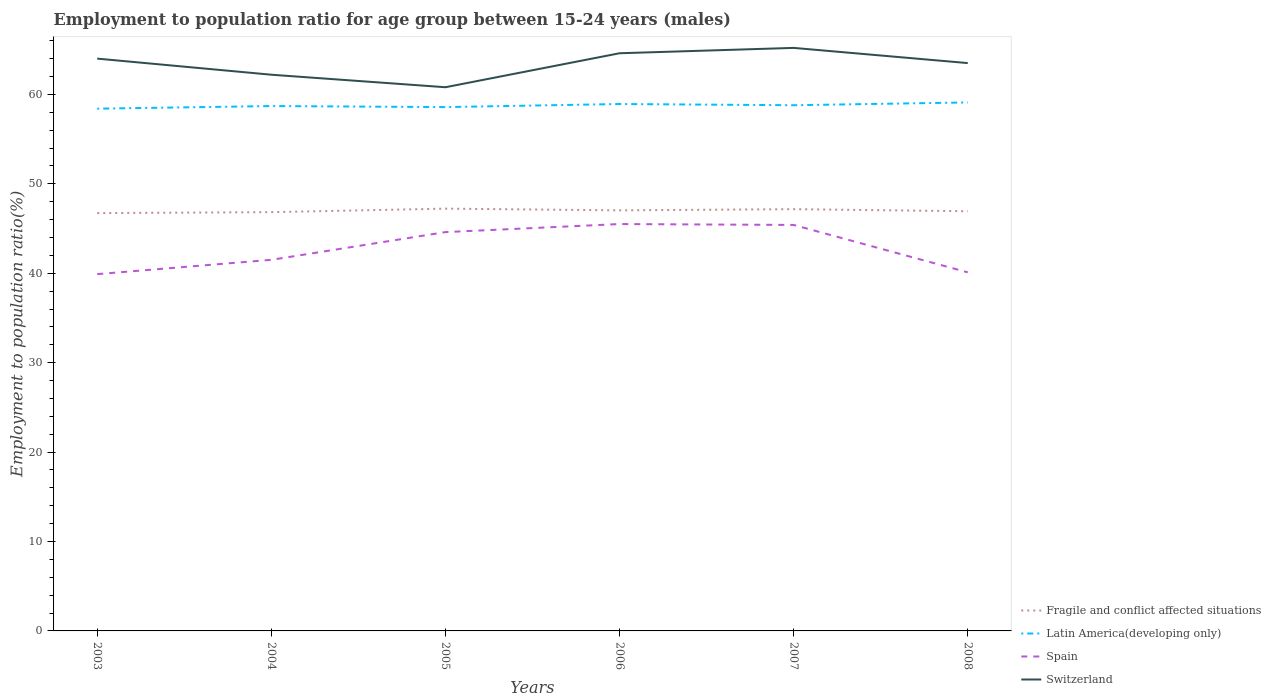How many different coloured lines are there?
Give a very brief answer. 4. Across all years, what is the maximum employment to population ratio in Fragile and conflict affected situations?
Offer a terse response. 46.72. What is the total employment to population ratio in Latin America(developing only) in the graph?
Give a very brief answer. -0.4. What is the difference between the highest and the second highest employment to population ratio in Spain?
Your answer should be very brief. 5.6. Is the employment to population ratio in Spain strictly greater than the employment to population ratio in Latin America(developing only) over the years?
Make the answer very short. Yes. How many years are there in the graph?
Give a very brief answer. 6. Does the graph contain any zero values?
Offer a terse response. No. Does the graph contain grids?
Make the answer very short. No. Where does the legend appear in the graph?
Provide a succinct answer. Bottom right. How many legend labels are there?
Offer a terse response. 4. How are the legend labels stacked?
Your answer should be compact. Vertical. What is the title of the graph?
Give a very brief answer. Employment to population ratio for age group between 15-24 years (males). Does "Guyana" appear as one of the legend labels in the graph?
Keep it short and to the point. No. What is the label or title of the X-axis?
Make the answer very short. Years. What is the label or title of the Y-axis?
Your response must be concise. Employment to population ratio(%). What is the Employment to population ratio(%) in Fragile and conflict affected situations in 2003?
Your answer should be compact. 46.72. What is the Employment to population ratio(%) of Latin America(developing only) in 2003?
Ensure brevity in your answer.  58.4. What is the Employment to population ratio(%) in Spain in 2003?
Give a very brief answer. 39.9. What is the Employment to population ratio(%) in Fragile and conflict affected situations in 2004?
Keep it short and to the point. 46.83. What is the Employment to population ratio(%) in Latin America(developing only) in 2004?
Ensure brevity in your answer.  58.7. What is the Employment to population ratio(%) in Spain in 2004?
Offer a very short reply. 41.5. What is the Employment to population ratio(%) in Switzerland in 2004?
Your answer should be compact. 62.2. What is the Employment to population ratio(%) of Fragile and conflict affected situations in 2005?
Ensure brevity in your answer.  47.22. What is the Employment to population ratio(%) of Latin America(developing only) in 2005?
Provide a short and direct response. 58.58. What is the Employment to population ratio(%) of Spain in 2005?
Provide a short and direct response. 44.6. What is the Employment to population ratio(%) of Switzerland in 2005?
Keep it short and to the point. 60.8. What is the Employment to population ratio(%) of Fragile and conflict affected situations in 2006?
Offer a terse response. 47.03. What is the Employment to population ratio(%) of Latin America(developing only) in 2006?
Your answer should be very brief. 58.92. What is the Employment to population ratio(%) of Spain in 2006?
Make the answer very short. 45.5. What is the Employment to population ratio(%) of Switzerland in 2006?
Offer a terse response. 64.6. What is the Employment to population ratio(%) in Fragile and conflict affected situations in 2007?
Your answer should be very brief. 47.16. What is the Employment to population ratio(%) in Latin America(developing only) in 2007?
Ensure brevity in your answer.  58.79. What is the Employment to population ratio(%) of Spain in 2007?
Offer a terse response. 45.4. What is the Employment to population ratio(%) in Switzerland in 2007?
Keep it short and to the point. 65.2. What is the Employment to population ratio(%) in Fragile and conflict affected situations in 2008?
Offer a terse response. 46.93. What is the Employment to population ratio(%) in Latin America(developing only) in 2008?
Your answer should be very brief. 59.1. What is the Employment to population ratio(%) of Spain in 2008?
Your answer should be compact. 40.1. What is the Employment to population ratio(%) of Switzerland in 2008?
Your answer should be compact. 63.5. Across all years, what is the maximum Employment to population ratio(%) in Fragile and conflict affected situations?
Offer a very short reply. 47.22. Across all years, what is the maximum Employment to population ratio(%) of Latin America(developing only)?
Offer a terse response. 59.1. Across all years, what is the maximum Employment to population ratio(%) in Spain?
Offer a very short reply. 45.5. Across all years, what is the maximum Employment to population ratio(%) in Switzerland?
Keep it short and to the point. 65.2. Across all years, what is the minimum Employment to population ratio(%) of Fragile and conflict affected situations?
Make the answer very short. 46.72. Across all years, what is the minimum Employment to population ratio(%) in Latin America(developing only)?
Keep it short and to the point. 58.4. Across all years, what is the minimum Employment to population ratio(%) in Spain?
Give a very brief answer. 39.9. Across all years, what is the minimum Employment to population ratio(%) in Switzerland?
Keep it short and to the point. 60.8. What is the total Employment to population ratio(%) in Fragile and conflict affected situations in the graph?
Give a very brief answer. 281.91. What is the total Employment to population ratio(%) of Latin America(developing only) in the graph?
Give a very brief answer. 352.49. What is the total Employment to population ratio(%) of Spain in the graph?
Your response must be concise. 257. What is the total Employment to population ratio(%) in Switzerland in the graph?
Make the answer very short. 380.3. What is the difference between the Employment to population ratio(%) in Fragile and conflict affected situations in 2003 and that in 2004?
Your answer should be compact. -0.11. What is the difference between the Employment to population ratio(%) of Latin America(developing only) in 2003 and that in 2004?
Provide a succinct answer. -0.29. What is the difference between the Employment to population ratio(%) of Spain in 2003 and that in 2004?
Ensure brevity in your answer.  -1.6. What is the difference between the Employment to population ratio(%) of Switzerland in 2003 and that in 2004?
Your response must be concise. 1.8. What is the difference between the Employment to population ratio(%) in Fragile and conflict affected situations in 2003 and that in 2005?
Give a very brief answer. -0.5. What is the difference between the Employment to population ratio(%) of Latin America(developing only) in 2003 and that in 2005?
Give a very brief answer. -0.18. What is the difference between the Employment to population ratio(%) of Switzerland in 2003 and that in 2005?
Ensure brevity in your answer.  3.2. What is the difference between the Employment to population ratio(%) in Fragile and conflict affected situations in 2003 and that in 2006?
Provide a short and direct response. -0.31. What is the difference between the Employment to population ratio(%) of Latin America(developing only) in 2003 and that in 2006?
Offer a terse response. -0.52. What is the difference between the Employment to population ratio(%) in Fragile and conflict affected situations in 2003 and that in 2007?
Keep it short and to the point. -0.44. What is the difference between the Employment to population ratio(%) of Latin America(developing only) in 2003 and that in 2007?
Provide a succinct answer. -0.39. What is the difference between the Employment to population ratio(%) in Fragile and conflict affected situations in 2003 and that in 2008?
Your answer should be very brief. -0.21. What is the difference between the Employment to population ratio(%) in Latin America(developing only) in 2003 and that in 2008?
Keep it short and to the point. -0.7. What is the difference between the Employment to population ratio(%) of Spain in 2003 and that in 2008?
Your response must be concise. -0.2. What is the difference between the Employment to population ratio(%) of Fragile and conflict affected situations in 2004 and that in 2005?
Provide a short and direct response. -0.39. What is the difference between the Employment to population ratio(%) in Latin America(developing only) in 2004 and that in 2005?
Give a very brief answer. 0.12. What is the difference between the Employment to population ratio(%) in Spain in 2004 and that in 2005?
Make the answer very short. -3.1. What is the difference between the Employment to population ratio(%) in Fragile and conflict affected situations in 2004 and that in 2006?
Give a very brief answer. -0.2. What is the difference between the Employment to population ratio(%) in Latin America(developing only) in 2004 and that in 2006?
Give a very brief answer. -0.23. What is the difference between the Employment to population ratio(%) in Switzerland in 2004 and that in 2006?
Your answer should be very brief. -2.4. What is the difference between the Employment to population ratio(%) in Fragile and conflict affected situations in 2004 and that in 2007?
Your response must be concise. -0.33. What is the difference between the Employment to population ratio(%) of Latin America(developing only) in 2004 and that in 2007?
Make the answer very short. -0.09. What is the difference between the Employment to population ratio(%) of Fragile and conflict affected situations in 2004 and that in 2008?
Your response must be concise. -0.1. What is the difference between the Employment to population ratio(%) of Latin America(developing only) in 2004 and that in 2008?
Provide a succinct answer. -0.4. What is the difference between the Employment to population ratio(%) of Spain in 2004 and that in 2008?
Make the answer very short. 1.4. What is the difference between the Employment to population ratio(%) in Fragile and conflict affected situations in 2005 and that in 2006?
Ensure brevity in your answer.  0.19. What is the difference between the Employment to population ratio(%) of Latin America(developing only) in 2005 and that in 2006?
Make the answer very short. -0.34. What is the difference between the Employment to population ratio(%) in Spain in 2005 and that in 2006?
Your answer should be compact. -0.9. What is the difference between the Employment to population ratio(%) of Switzerland in 2005 and that in 2006?
Offer a terse response. -3.8. What is the difference between the Employment to population ratio(%) of Fragile and conflict affected situations in 2005 and that in 2007?
Offer a very short reply. 0.06. What is the difference between the Employment to population ratio(%) of Latin America(developing only) in 2005 and that in 2007?
Give a very brief answer. -0.21. What is the difference between the Employment to population ratio(%) in Fragile and conflict affected situations in 2005 and that in 2008?
Provide a short and direct response. 0.29. What is the difference between the Employment to population ratio(%) in Latin America(developing only) in 2005 and that in 2008?
Give a very brief answer. -0.52. What is the difference between the Employment to population ratio(%) of Spain in 2005 and that in 2008?
Offer a very short reply. 4.5. What is the difference between the Employment to population ratio(%) in Switzerland in 2005 and that in 2008?
Your answer should be compact. -2.7. What is the difference between the Employment to population ratio(%) in Fragile and conflict affected situations in 2006 and that in 2007?
Provide a short and direct response. -0.13. What is the difference between the Employment to population ratio(%) in Latin America(developing only) in 2006 and that in 2007?
Your answer should be compact. 0.13. What is the difference between the Employment to population ratio(%) in Spain in 2006 and that in 2007?
Offer a very short reply. 0.1. What is the difference between the Employment to population ratio(%) in Fragile and conflict affected situations in 2006 and that in 2008?
Ensure brevity in your answer.  0.1. What is the difference between the Employment to population ratio(%) in Latin America(developing only) in 2006 and that in 2008?
Your answer should be very brief. -0.18. What is the difference between the Employment to population ratio(%) of Fragile and conflict affected situations in 2007 and that in 2008?
Ensure brevity in your answer.  0.23. What is the difference between the Employment to population ratio(%) in Latin America(developing only) in 2007 and that in 2008?
Your response must be concise. -0.31. What is the difference between the Employment to population ratio(%) of Switzerland in 2007 and that in 2008?
Your response must be concise. 1.7. What is the difference between the Employment to population ratio(%) in Fragile and conflict affected situations in 2003 and the Employment to population ratio(%) in Latin America(developing only) in 2004?
Make the answer very short. -11.97. What is the difference between the Employment to population ratio(%) of Fragile and conflict affected situations in 2003 and the Employment to population ratio(%) of Spain in 2004?
Give a very brief answer. 5.22. What is the difference between the Employment to population ratio(%) of Fragile and conflict affected situations in 2003 and the Employment to population ratio(%) of Switzerland in 2004?
Make the answer very short. -15.48. What is the difference between the Employment to population ratio(%) in Latin America(developing only) in 2003 and the Employment to population ratio(%) in Spain in 2004?
Your response must be concise. 16.9. What is the difference between the Employment to population ratio(%) in Latin America(developing only) in 2003 and the Employment to population ratio(%) in Switzerland in 2004?
Keep it short and to the point. -3.8. What is the difference between the Employment to population ratio(%) in Spain in 2003 and the Employment to population ratio(%) in Switzerland in 2004?
Provide a short and direct response. -22.3. What is the difference between the Employment to population ratio(%) of Fragile and conflict affected situations in 2003 and the Employment to population ratio(%) of Latin America(developing only) in 2005?
Make the answer very short. -11.86. What is the difference between the Employment to population ratio(%) of Fragile and conflict affected situations in 2003 and the Employment to population ratio(%) of Spain in 2005?
Make the answer very short. 2.12. What is the difference between the Employment to population ratio(%) in Fragile and conflict affected situations in 2003 and the Employment to population ratio(%) in Switzerland in 2005?
Keep it short and to the point. -14.08. What is the difference between the Employment to population ratio(%) of Latin America(developing only) in 2003 and the Employment to population ratio(%) of Spain in 2005?
Offer a very short reply. 13.8. What is the difference between the Employment to population ratio(%) of Latin America(developing only) in 2003 and the Employment to population ratio(%) of Switzerland in 2005?
Your answer should be compact. -2.4. What is the difference between the Employment to population ratio(%) in Spain in 2003 and the Employment to population ratio(%) in Switzerland in 2005?
Your answer should be compact. -20.9. What is the difference between the Employment to population ratio(%) of Fragile and conflict affected situations in 2003 and the Employment to population ratio(%) of Latin America(developing only) in 2006?
Offer a terse response. -12.2. What is the difference between the Employment to population ratio(%) in Fragile and conflict affected situations in 2003 and the Employment to population ratio(%) in Spain in 2006?
Offer a very short reply. 1.22. What is the difference between the Employment to population ratio(%) of Fragile and conflict affected situations in 2003 and the Employment to population ratio(%) of Switzerland in 2006?
Offer a very short reply. -17.88. What is the difference between the Employment to population ratio(%) in Latin America(developing only) in 2003 and the Employment to population ratio(%) in Spain in 2006?
Offer a very short reply. 12.9. What is the difference between the Employment to population ratio(%) of Latin America(developing only) in 2003 and the Employment to population ratio(%) of Switzerland in 2006?
Provide a short and direct response. -6.2. What is the difference between the Employment to population ratio(%) of Spain in 2003 and the Employment to population ratio(%) of Switzerland in 2006?
Offer a very short reply. -24.7. What is the difference between the Employment to population ratio(%) of Fragile and conflict affected situations in 2003 and the Employment to population ratio(%) of Latin America(developing only) in 2007?
Make the answer very short. -12.06. What is the difference between the Employment to population ratio(%) in Fragile and conflict affected situations in 2003 and the Employment to population ratio(%) in Spain in 2007?
Your answer should be compact. 1.32. What is the difference between the Employment to population ratio(%) in Fragile and conflict affected situations in 2003 and the Employment to population ratio(%) in Switzerland in 2007?
Ensure brevity in your answer.  -18.48. What is the difference between the Employment to population ratio(%) in Latin America(developing only) in 2003 and the Employment to population ratio(%) in Spain in 2007?
Your answer should be very brief. 13. What is the difference between the Employment to population ratio(%) of Latin America(developing only) in 2003 and the Employment to population ratio(%) of Switzerland in 2007?
Give a very brief answer. -6.8. What is the difference between the Employment to population ratio(%) in Spain in 2003 and the Employment to population ratio(%) in Switzerland in 2007?
Offer a terse response. -25.3. What is the difference between the Employment to population ratio(%) of Fragile and conflict affected situations in 2003 and the Employment to population ratio(%) of Latin America(developing only) in 2008?
Your response must be concise. -12.38. What is the difference between the Employment to population ratio(%) of Fragile and conflict affected situations in 2003 and the Employment to population ratio(%) of Spain in 2008?
Offer a very short reply. 6.62. What is the difference between the Employment to population ratio(%) of Fragile and conflict affected situations in 2003 and the Employment to population ratio(%) of Switzerland in 2008?
Your answer should be very brief. -16.78. What is the difference between the Employment to population ratio(%) in Latin America(developing only) in 2003 and the Employment to population ratio(%) in Spain in 2008?
Keep it short and to the point. 18.3. What is the difference between the Employment to population ratio(%) in Latin America(developing only) in 2003 and the Employment to population ratio(%) in Switzerland in 2008?
Your response must be concise. -5.1. What is the difference between the Employment to population ratio(%) in Spain in 2003 and the Employment to population ratio(%) in Switzerland in 2008?
Ensure brevity in your answer.  -23.6. What is the difference between the Employment to population ratio(%) of Fragile and conflict affected situations in 2004 and the Employment to population ratio(%) of Latin America(developing only) in 2005?
Keep it short and to the point. -11.75. What is the difference between the Employment to population ratio(%) in Fragile and conflict affected situations in 2004 and the Employment to population ratio(%) in Spain in 2005?
Provide a short and direct response. 2.23. What is the difference between the Employment to population ratio(%) in Fragile and conflict affected situations in 2004 and the Employment to population ratio(%) in Switzerland in 2005?
Offer a very short reply. -13.97. What is the difference between the Employment to population ratio(%) of Latin America(developing only) in 2004 and the Employment to population ratio(%) of Spain in 2005?
Your response must be concise. 14.1. What is the difference between the Employment to population ratio(%) of Latin America(developing only) in 2004 and the Employment to population ratio(%) of Switzerland in 2005?
Make the answer very short. -2.1. What is the difference between the Employment to population ratio(%) of Spain in 2004 and the Employment to population ratio(%) of Switzerland in 2005?
Offer a very short reply. -19.3. What is the difference between the Employment to population ratio(%) in Fragile and conflict affected situations in 2004 and the Employment to population ratio(%) in Latin America(developing only) in 2006?
Give a very brief answer. -12.09. What is the difference between the Employment to population ratio(%) of Fragile and conflict affected situations in 2004 and the Employment to population ratio(%) of Spain in 2006?
Ensure brevity in your answer.  1.33. What is the difference between the Employment to population ratio(%) of Fragile and conflict affected situations in 2004 and the Employment to population ratio(%) of Switzerland in 2006?
Keep it short and to the point. -17.77. What is the difference between the Employment to population ratio(%) of Latin America(developing only) in 2004 and the Employment to population ratio(%) of Spain in 2006?
Offer a terse response. 13.2. What is the difference between the Employment to population ratio(%) of Latin America(developing only) in 2004 and the Employment to population ratio(%) of Switzerland in 2006?
Make the answer very short. -5.9. What is the difference between the Employment to population ratio(%) in Spain in 2004 and the Employment to population ratio(%) in Switzerland in 2006?
Ensure brevity in your answer.  -23.1. What is the difference between the Employment to population ratio(%) of Fragile and conflict affected situations in 2004 and the Employment to population ratio(%) of Latin America(developing only) in 2007?
Your answer should be compact. -11.96. What is the difference between the Employment to population ratio(%) of Fragile and conflict affected situations in 2004 and the Employment to population ratio(%) of Spain in 2007?
Provide a succinct answer. 1.43. What is the difference between the Employment to population ratio(%) of Fragile and conflict affected situations in 2004 and the Employment to population ratio(%) of Switzerland in 2007?
Provide a succinct answer. -18.37. What is the difference between the Employment to population ratio(%) of Latin America(developing only) in 2004 and the Employment to population ratio(%) of Spain in 2007?
Your answer should be very brief. 13.3. What is the difference between the Employment to population ratio(%) in Latin America(developing only) in 2004 and the Employment to population ratio(%) in Switzerland in 2007?
Ensure brevity in your answer.  -6.5. What is the difference between the Employment to population ratio(%) in Spain in 2004 and the Employment to population ratio(%) in Switzerland in 2007?
Your answer should be compact. -23.7. What is the difference between the Employment to population ratio(%) of Fragile and conflict affected situations in 2004 and the Employment to population ratio(%) of Latin America(developing only) in 2008?
Ensure brevity in your answer.  -12.27. What is the difference between the Employment to population ratio(%) in Fragile and conflict affected situations in 2004 and the Employment to population ratio(%) in Spain in 2008?
Give a very brief answer. 6.73. What is the difference between the Employment to population ratio(%) of Fragile and conflict affected situations in 2004 and the Employment to population ratio(%) of Switzerland in 2008?
Offer a very short reply. -16.67. What is the difference between the Employment to population ratio(%) of Latin America(developing only) in 2004 and the Employment to population ratio(%) of Spain in 2008?
Provide a short and direct response. 18.6. What is the difference between the Employment to population ratio(%) of Latin America(developing only) in 2004 and the Employment to population ratio(%) of Switzerland in 2008?
Give a very brief answer. -4.8. What is the difference between the Employment to population ratio(%) of Fragile and conflict affected situations in 2005 and the Employment to population ratio(%) of Latin America(developing only) in 2006?
Your answer should be compact. -11.7. What is the difference between the Employment to population ratio(%) of Fragile and conflict affected situations in 2005 and the Employment to population ratio(%) of Spain in 2006?
Make the answer very short. 1.72. What is the difference between the Employment to population ratio(%) of Fragile and conflict affected situations in 2005 and the Employment to population ratio(%) of Switzerland in 2006?
Keep it short and to the point. -17.38. What is the difference between the Employment to population ratio(%) of Latin America(developing only) in 2005 and the Employment to population ratio(%) of Spain in 2006?
Your response must be concise. 13.08. What is the difference between the Employment to population ratio(%) of Latin America(developing only) in 2005 and the Employment to population ratio(%) of Switzerland in 2006?
Ensure brevity in your answer.  -6.02. What is the difference between the Employment to population ratio(%) of Spain in 2005 and the Employment to population ratio(%) of Switzerland in 2006?
Offer a very short reply. -20. What is the difference between the Employment to population ratio(%) in Fragile and conflict affected situations in 2005 and the Employment to population ratio(%) in Latin America(developing only) in 2007?
Your answer should be very brief. -11.57. What is the difference between the Employment to population ratio(%) in Fragile and conflict affected situations in 2005 and the Employment to population ratio(%) in Spain in 2007?
Keep it short and to the point. 1.82. What is the difference between the Employment to population ratio(%) in Fragile and conflict affected situations in 2005 and the Employment to population ratio(%) in Switzerland in 2007?
Give a very brief answer. -17.98. What is the difference between the Employment to population ratio(%) in Latin America(developing only) in 2005 and the Employment to population ratio(%) in Spain in 2007?
Offer a very short reply. 13.18. What is the difference between the Employment to population ratio(%) of Latin America(developing only) in 2005 and the Employment to population ratio(%) of Switzerland in 2007?
Your response must be concise. -6.62. What is the difference between the Employment to population ratio(%) of Spain in 2005 and the Employment to population ratio(%) of Switzerland in 2007?
Give a very brief answer. -20.6. What is the difference between the Employment to population ratio(%) in Fragile and conflict affected situations in 2005 and the Employment to population ratio(%) in Latin America(developing only) in 2008?
Offer a terse response. -11.88. What is the difference between the Employment to population ratio(%) of Fragile and conflict affected situations in 2005 and the Employment to population ratio(%) of Spain in 2008?
Offer a terse response. 7.12. What is the difference between the Employment to population ratio(%) of Fragile and conflict affected situations in 2005 and the Employment to population ratio(%) of Switzerland in 2008?
Ensure brevity in your answer.  -16.28. What is the difference between the Employment to population ratio(%) of Latin America(developing only) in 2005 and the Employment to population ratio(%) of Spain in 2008?
Your response must be concise. 18.48. What is the difference between the Employment to population ratio(%) of Latin America(developing only) in 2005 and the Employment to population ratio(%) of Switzerland in 2008?
Your response must be concise. -4.92. What is the difference between the Employment to population ratio(%) in Spain in 2005 and the Employment to population ratio(%) in Switzerland in 2008?
Your answer should be very brief. -18.9. What is the difference between the Employment to population ratio(%) in Fragile and conflict affected situations in 2006 and the Employment to population ratio(%) in Latin America(developing only) in 2007?
Offer a terse response. -11.76. What is the difference between the Employment to population ratio(%) in Fragile and conflict affected situations in 2006 and the Employment to population ratio(%) in Spain in 2007?
Keep it short and to the point. 1.63. What is the difference between the Employment to population ratio(%) of Fragile and conflict affected situations in 2006 and the Employment to population ratio(%) of Switzerland in 2007?
Provide a short and direct response. -18.17. What is the difference between the Employment to population ratio(%) of Latin America(developing only) in 2006 and the Employment to population ratio(%) of Spain in 2007?
Your response must be concise. 13.52. What is the difference between the Employment to population ratio(%) in Latin America(developing only) in 2006 and the Employment to population ratio(%) in Switzerland in 2007?
Your answer should be very brief. -6.28. What is the difference between the Employment to population ratio(%) of Spain in 2006 and the Employment to population ratio(%) of Switzerland in 2007?
Ensure brevity in your answer.  -19.7. What is the difference between the Employment to population ratio(%) in Fragile and conflict affected situations in 2006 and the Employment to population ratio(%) in Latin America(developing only) in 2008?
Make the answer very short. -12.07. What is the difference between the Employment to population ratio(%) in Fragile and conflict affected situations in 2006 and the Employment to population ratio(%) in Spain in 2008?
Your answer should be very brief. 6.93. What is the difference between the Employment to population ratio(%) of Fragile and conflict affected situations in 2006 and the Employment to population ratio(%) of Switzerland in 2008?
Your answer should be very brief. -16.47. What is the difference between the Employment to population ratio(%) in Latin America(developing only) in 2006 and the Employment to population ratio(%) in Spain in 2008?
Offer a very short reply. 18.82. What is the difference between the Employment to population ratio(%) of Latin America(developing only) in 2006 and the Employment to population ratio(%) of Switzerland in 2008?
Make the answer very short. -4.58. What is the difference between the Employment to population ratio(%) in Fragile and conflict affected situations in 2007 and the Employment to population ratio(%) in Latin America(developing only) in 2008?
Offer a very short reply. -11.93. What is the difference between the Employment to population ratio(%) of Fragile and conflict affected situations in 2007 and the Employment to population ratio(%) of Spain in 2008?
Offer a terse response. 7.06. What is the difference between the Employment to population ratio(%) of Fragile and conflict affected situations in 2007 and the Employment to population ratio(%) of Switzerland in 2008?
Offer a terse response. -16.34. What is the difference between the Employment to population ratio(%) of Latin America(developing only) in 2007 and the Employment to population ratio(%) of Spain in 2008?
Your response must be concise. 18.69. What is the difference between the Employment to population ratio(%) in Latin America(developing only) in 2007 and the Employment to population ratio(%) in Switzerland in 2008?
Provide a succinct answer. -4.71. What is the difference between the Employment to population ratio(%) in Spain in 2007 and the Employment to population ratio(%) in Switzerland in 2008?
Provide a succinct answer. -18.1. What is the average Employment to population ratio(%) in Fragile and conflict affected situations per year?
Offer a very short reply. 46.98. What is the average Employment to population ratio(%) in Latin America(developing only) per year?
Give a very brief answer. 58.75. What is the average Employment to population ratio(%) of Spain per year?
Provide a succinct answer. 42.83. What is the average Employment to population ratio(%) in Switzerland per year?
Give a very brief answer. 63.38. In the year 2003, what is the difference between the Employment to population ratio(%) of Fragile and conflict affected situations and Employment to population ratio(%) of Latin America(developing only)?
Ensure brevity in your answer.  -11.68. In the year 2003, what is the difference between the Employment to population ratio(%) in Fragile and conflict affected situations and Employment to population ratio(%) in Spain?
Give a very brief answer. 6.82. In the year 2003, what is the difference between the Employment to population ratio(%) of Fragile and conflict affected situations and Employment to population ratio(%) of Switzerland?
Give a very brief answer. -17.28. In the year 2003, what is the difference between the Employment to population ratio(%) of Latin America(developing only) and Employment to population ratio(%) of Spain?
Make the answer very short. 18.5. In the year 2003, what is the difference between the Employment to population ratio(%) of Latin America(developing only) and Employment to population ratio(%) of Switzerland?
Your answer should be very brief. -5.6. In the year 2003, what is the difference between the Employment to population ratio(%) in Spain and Employment to population ratio(%) in Switzerland?
Your response must be concise. -24.1. In the year 2004, what is the difference between the Employment to population ratio(%) in Fragile and conflict affected situations and Employment to population ratio(%) in Latin America(developing only)?
Keep it short and to the point. -11.87. In the year 2004, what is the difference between the Employment to population ratio(%) of Fragile and conflict affected situations and Employment to population ratio(%) of Spain?
Your response must be concise. 5.33. In the year 2004, what is the difference between the Employment to population ratio(%) in Fragile and conflict affected situations and Employment to population ratio(%) in Switzerland?
Keep it short and to the point. -15.37. In the year 2004, what is the difference between the Employment to population ratio(%) in Latin America(developing only) and Employment to population ratio(%) in Spain?
Offer a terse response. 17.2. In the year 2004, what is the difference between the Employment to population ratio(%) in Latin America(developing only) and Employment to population ratio(%) in Switzerland?
Ensure brevity in your answer.  -3.5. In the year 2004, what is the difference between the Employment to population ratio(%) of Spain and Employment to population ratio(%) of Switzerland?
Provide a succinct answer. -20.7. In the year 2005, what is the difference between the Employment to population ratio(%) in Fragile and conflict affected situations and Employment to population ratio(%) in Latin America(developing only)?
Provide a succinct answer. -11.36. In the year 2005, what is the difference between the Employment to population ratio(%) in Fragile and conflict affected situations and Employment to population ratio(%) in Spain?
Give a very brief answer. 2.62. In the year 2005, what is the difference between the Employment to population ratio(%) in Fragile and conflict affected situations and Employment to population ratio(%) in Switzerland?
Make the answer very short. -13.58. In the year 2005, what is the difference between the Employment to population ratio(%) of Latin America(developing only) and Employment to population ratio(%) of Spain?
Provide a succinct answer. 13.98. In the year 2005, what is the difference between the Employment to population ratio(%) in Latin America(developing only) and Employment to population ratio(%) in Switzerland?
Make the answer very short. -2.22. In the year 2005, what is the difference between the Employment to population ratio(%) in Spain and Employment to population ratio(%) in Switzerland?
Make the answer very short. -16.2. In the year 2006, what is the difference between the Employment to population ratio(%) in Fragile and conflict affected situations and Employment to population ratio(%) in Latin America(developing only)?
Your response must be concise. -11.89. In the year 2006, what is the difference between the Employment to population ratio(%) of Fragile and conflict affected situations and Employment to population ratio(%) of Spain?
Your answer should be very brief. 1.53. In the year 2006, what is the difference between the Employment to population ratio(%) of Fragile and conflict affected situations and Employment to population ratio(%) of Switzerland?
Provide a short and direct response. -17.57. In the year 2006, what is the difference between the Employment to population ratio(%) of Latin America(developing only) and Employment to population ratio(%) of Spain?
Make the answer very short. 13.42. In the year 2006, what is the difference between the Employment to population ratio(%) of Latin America(developing only) and Employment to population ratio(%) of Switzerland?
Your response must be concise. -5.68. In the year 2006, what is the difference between the Employment to population ratio(%) of Spain and Employment to population ratio(%) of Switzerland?
Offer a very short reply. -19.1. In the year 2007, what is the difference between the Employment to population ratio(%) of Fragile and conflict affected situations and Employment to population ratio(%) of Latin America(developing only)?
Provide a short and direct response. -11.62. In the year 2007, what is the difference between the Employment to population ratio(%) of Fragile and conflict affected situations and Employment to population ratio(%) of Spain?
Give a very brief answer. 1.76. In the year 2007, what is the difference between the Employment to population ratio(%) of Fragile and conflict affected situations and Employment to population ratio(%) of Switzerland?
Make the answer very short. -18.04. In the year 2007, what is the difference between the Employment to population ratio(%) of Latin America(developing only) and Employment to population ratio(%) of Spain?
Give a very brief answer. 13.39. In the year 2007, what is the difference between the Employment to population ratio(%) of Latin America(developing only) and Employment to population ratio(%) of Switzerland?
Keep it short and to the point. -6.41. In the year 2007, what is the difference between the Employment to population ratio(%) in Spain and Employment to population ratio(%) in Switzerland?
Give a very brief answer. -19.8. In the year 2008, what is the difference between the Employment to population ratio(%) in Fragile and conflict affected situations and Employment to population ratio(%) in Latin America(developing only)?
Make the answer very short. -12.17. In the year 2008, what is the difference between the Employment to population ratio(%) in Fragile and conflict affected situations and Employment to population ratio(%) in Spain?
Give a very brief answer. 6.83. In the year 2008, what is the difference between the Employment to population ratio(%) of Fragile and conflict affected situations and Employment to population ratio(%) of Switzerland?
Your answer should be very brief. -16.57. In the year 2008, what is the difference between the Employment to population ratio(%) in Latin America(developing only) and Employment to population ratio(%) in Spain?
Your answer should be compact. 19. In the year 2008, what is the difference between the Employment to population ratio(%) of Latin America(developing only) and Employment to population ratio(%) of Switzerland?
Offer a terse response. -4.4. In the year 2008, what is the difference between the Employment to population ratio(%) of Spain and Employment to population ratio(%) of Switzerland?
Your response must be concise. -23.4. What is the ratio of the Employment to population ratio(%) in Latin America(developing only) in 2003 to that in 2004?
Your answer should be very brief. 0.99. What is the ratio of the Employment to population ratio(%) in Spain in 2003 to that in 2004?
Your answer should be compact. 0.96. What is the ratio of the Employment to population ratio(%) in Switzerland in 2003 to that in 2004?
Your answer should be very brief. 1.03. What is the ratio of the Employment to population ratio(%) of Spain in 2003 to that in 2005?
Your answer should be compact. 0.89. What is the ratio of the Employment to population ratio(%) in Switzerland in 2003 to that in 2005?
Keep it short and to the point. 1.05. What is the ratio of the Employment to population ratio(%) of Fragile and conflict affected situations in 2003 to that in 2006?
Your answer should be very brief. 0.99. What is the ratio of the Employment to population ratio(%) of Spain in 2003 to that in 2006?
Offer a very short reply. 0.88. What is the ratio of the Employment to population ratio(%) in Switzerland in 2003 to that in 2006?
Ensure brevity in your answer.  0.99. What is the ratio of the Employment to population ratio(%) of Latin America(developing only) in 2003 to that in 2007?
Offer a very short reply. 0.99. What is the ratio of the Employment to population ratio(%) of Spain in 2003 to that in 2007?
Offer a terse response. 0.88. What is the ratio of the Employment to population ratio(%) of Switzerland in 2003 to that in 2007?
Provide a short and direct response. 0.98. What is the ratio of the Employment to population ratio(%) in Fragile and conflict affected situations in 2003 to that in 2008?
Make the answer very short. 1. What is the ratio of the Employment to population ratio(%) in Switzerland in 2003 to that in 2008?
Give a very brief answer. 1.01. What is the ratio of the Employment to population ratio(%) in Fragile and conflict affected situations in 2004 to that in 2005?
Your answer should be compact. 0.99. What is the ratio of the Employment to population ratio(%) of Spain in 2004 to that in 2005?
Your answer should be compact. 0.93. What is the ratio of the Employment to population ratio(%) of Switzerland in 2004 to that in 2005?
Ensure brevity in your answer.  1.02. What is the ratio of the Employment to population ratio(%) of Fragile and conflict affected situations in 2004 to that in 2006?
Provide a succinct answer. 1. What is the ratio of the Employment to population ratio(%) in Latin America(developing only) in 2004 to that in 2006?
Ensure brevity in your answer.  1. What is the ratio of the Employment to population ratio(%) of Spain in 2004 to that in 2006?
Offer a very short reply. 0.91. What is the ratio of the Employment to population ratio(%) in Switzerland in 2004 to that in 2006?
Keep it short and to the point. 0.96. What is the ratio of the Employment to population ratio(%) of Fragile and conflict affected situations in 2004 to that in 2007?
Make the answer very short. 0.99. What is the ratio of the Employment to population ratio(%) in Spain in 2004 to that in 2007?
Provide a succinct answer. 0.91. What is the ratio of the Employment to population ratio(%) of Switzerland in 2004 to that in 2007?
Provide a succinct answer. 0.95. What is the ratio of the Employment to population ratio(%) in Fragile and conflict affected situations in 2004 to that in 2008?
Make the answer very short. 1. What is the ratio of the Employment to population ratio(%) of Spain in 2004 to that in 2008?
Your response must be concise. 1.03. What is the ratio of the Employment to population ratio(%) in Switzerland in 2004 to that in 2008?
Provide a short and direct response. 0.98. What is the ratio of the Employment to population ratio(%) in Latin America(developing only) in 2005 to that in 2006?
Ensure brevity in your answer.  0.99. What is the ratio of the Employment to population ratio(%) of Spain in 2005 to that in 2006?
Your answer should be compact. 0.98. What is the ratio of the Employment to population ratio(%) of Spain in 2005 to that in 2007?
Offer a terse response. 0.98. What is the ratio of the Employment to population ratio(%) of Switzerland in 2005 to that in 2007?
Provide a short and direct response. 0.93. What is the ratio of the Employment to population ratio(%) in Latin America(developing only) in 2005 to that in 2008?
Your answer should be compact. 0.99. What is the ratio of the Employment to population ratio(%) in Spain in 2005 to that in 2008?
Keep it short and to the point. 1.11. What is the ratio of the Employment to population ratio(%) in Switzerland in 2005 to that in 2008?
Ensure brevity in your answer.  0.96. What is the ratio of the Employment to population ratio(%) of Fragile and conflict affected situations in 2006 to that in 2007?
Provide a short and direct response. 1. What is the ratio of the Employment to population ratio(%) of Latin America(developing only) in 2006 to that in 2007?
Keep it short and to the point. 1. What is the ratio of the Employment to population ratio(%) in Fragile and conflict affected situations in 2006 to that in 2008?
Keep it short and to the point. 1. What is the ratio of the Employment to population ratio(%) in Spain in 2006 to that in 2008?
Offer a terse response. 1.13. What is the ratio of the Employment to population ratio(%) of Switzerland in 2006 to that in 2008?
Provide a short and direct response. 1.02. What is the ratio of the Employment to population ratio(%) in Spain in 2007 to that in 2008?
Offer a very short reply. 1.13. What is the ratio of the Employment to population ratio(%) in Switzerland in 2007 to that in 2008?
Your response must be concise. 1.03. What is the difference between the highest and the second highest Employment to population ratio(%) of Fragile and conflict affected situations?
Keep it short and to the point. 0.06. What is the difference between the highest and the second highest Employment to population ratio(%) of Latin America(developing only)?
Keep it short and to the point. 0.18. What is the difference between the highest and the second highest Employment to population ratio(%) of Spain?
Your answer should be very brief. 0.1. What is the difference between the highest and the lowest Employment to population ratio(%) of Fragile and conflict affected situations?
Your response must be concise. 0.5. What is the difference between the highest and the lowest Employment to population ratio(%) in Latin America(developing only)?
Give a very brief answer. 0.7. What is the difference between the highest and the lowest Employment to population ratio(%) in Spain?
Offer a very short reply. 5.6. 